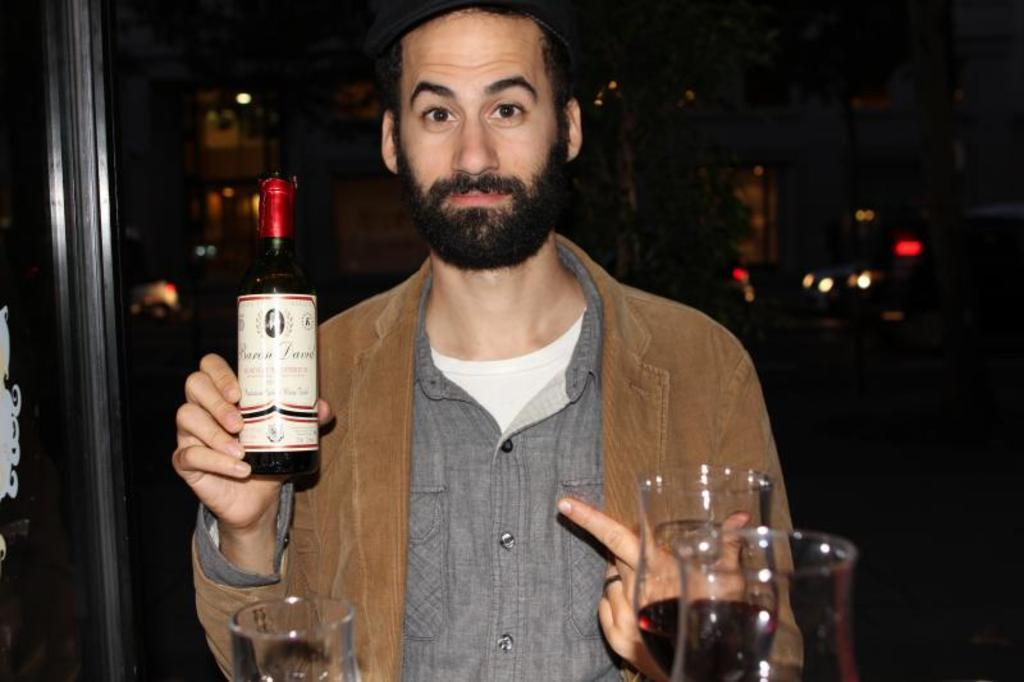Who or what is present in the image? There is a person in the image. What is the person holding in the image? The person is holding a bottle. What objects can be seen on the right side of the image? There are two glasses on the right side of the image. What can be seen in the background of the image? There is a building in the background of the image. How does the person show their appreciation for the drink in the image? The image does not show the person expressing appreciation for the drink, as it only depicts them holding a bottle. 